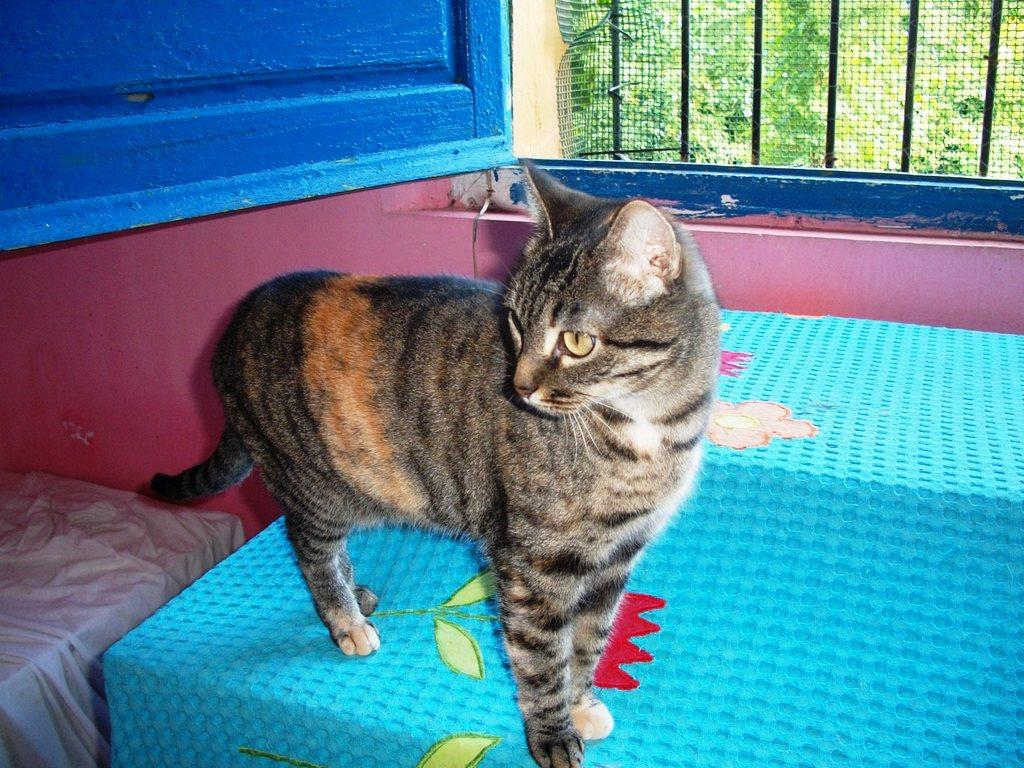What animal is standing in the image? There is a cat standing in the image. What else can be seen in the image besides the cat? Clothes, a wall, a window, iron grilles, and trees in the background are visible in the image. What type of architectural feature is present in the image? There is a wall and a window with iron grilles in the image. What can be seen in the background of the image? Trees are visible in the background of the image. What type of riddle can be solved by the cat in the image? There is no riddle present in the image, nor is there any indication that the cat is solving a riddle. 